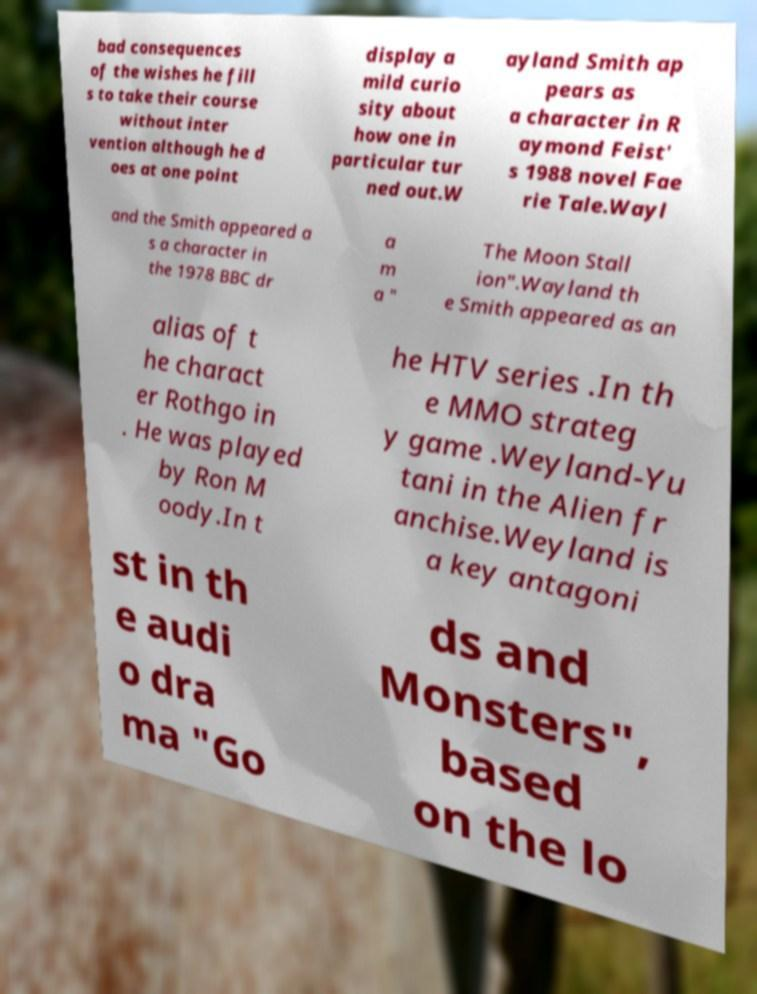Can you accurately transcribe the text from the provided image for me? bad consequences of the wishes he fill s to take their course without inter vention although he d oes at one point display a mild curio sity about how one in particular tur ned out.W ayland Smith ap pears as a character in R aymond Feist' s 1988 novel Fae rie Tale.Wayl and the Smith appeared a s a character in the 1978 BBC dr a m a " The Moon Stall ion".Wayland th e Smith appeared as an alias of t he charact er Rothgo in . He was played by Ron M oody.In t he HTV series .In th e MMO strateg y game .Weyland-Yu tani in the Alien fr anchise.Weyland is a key antagoni st in th e audi o dra ma "Go ds and Monsters", based on the lo 